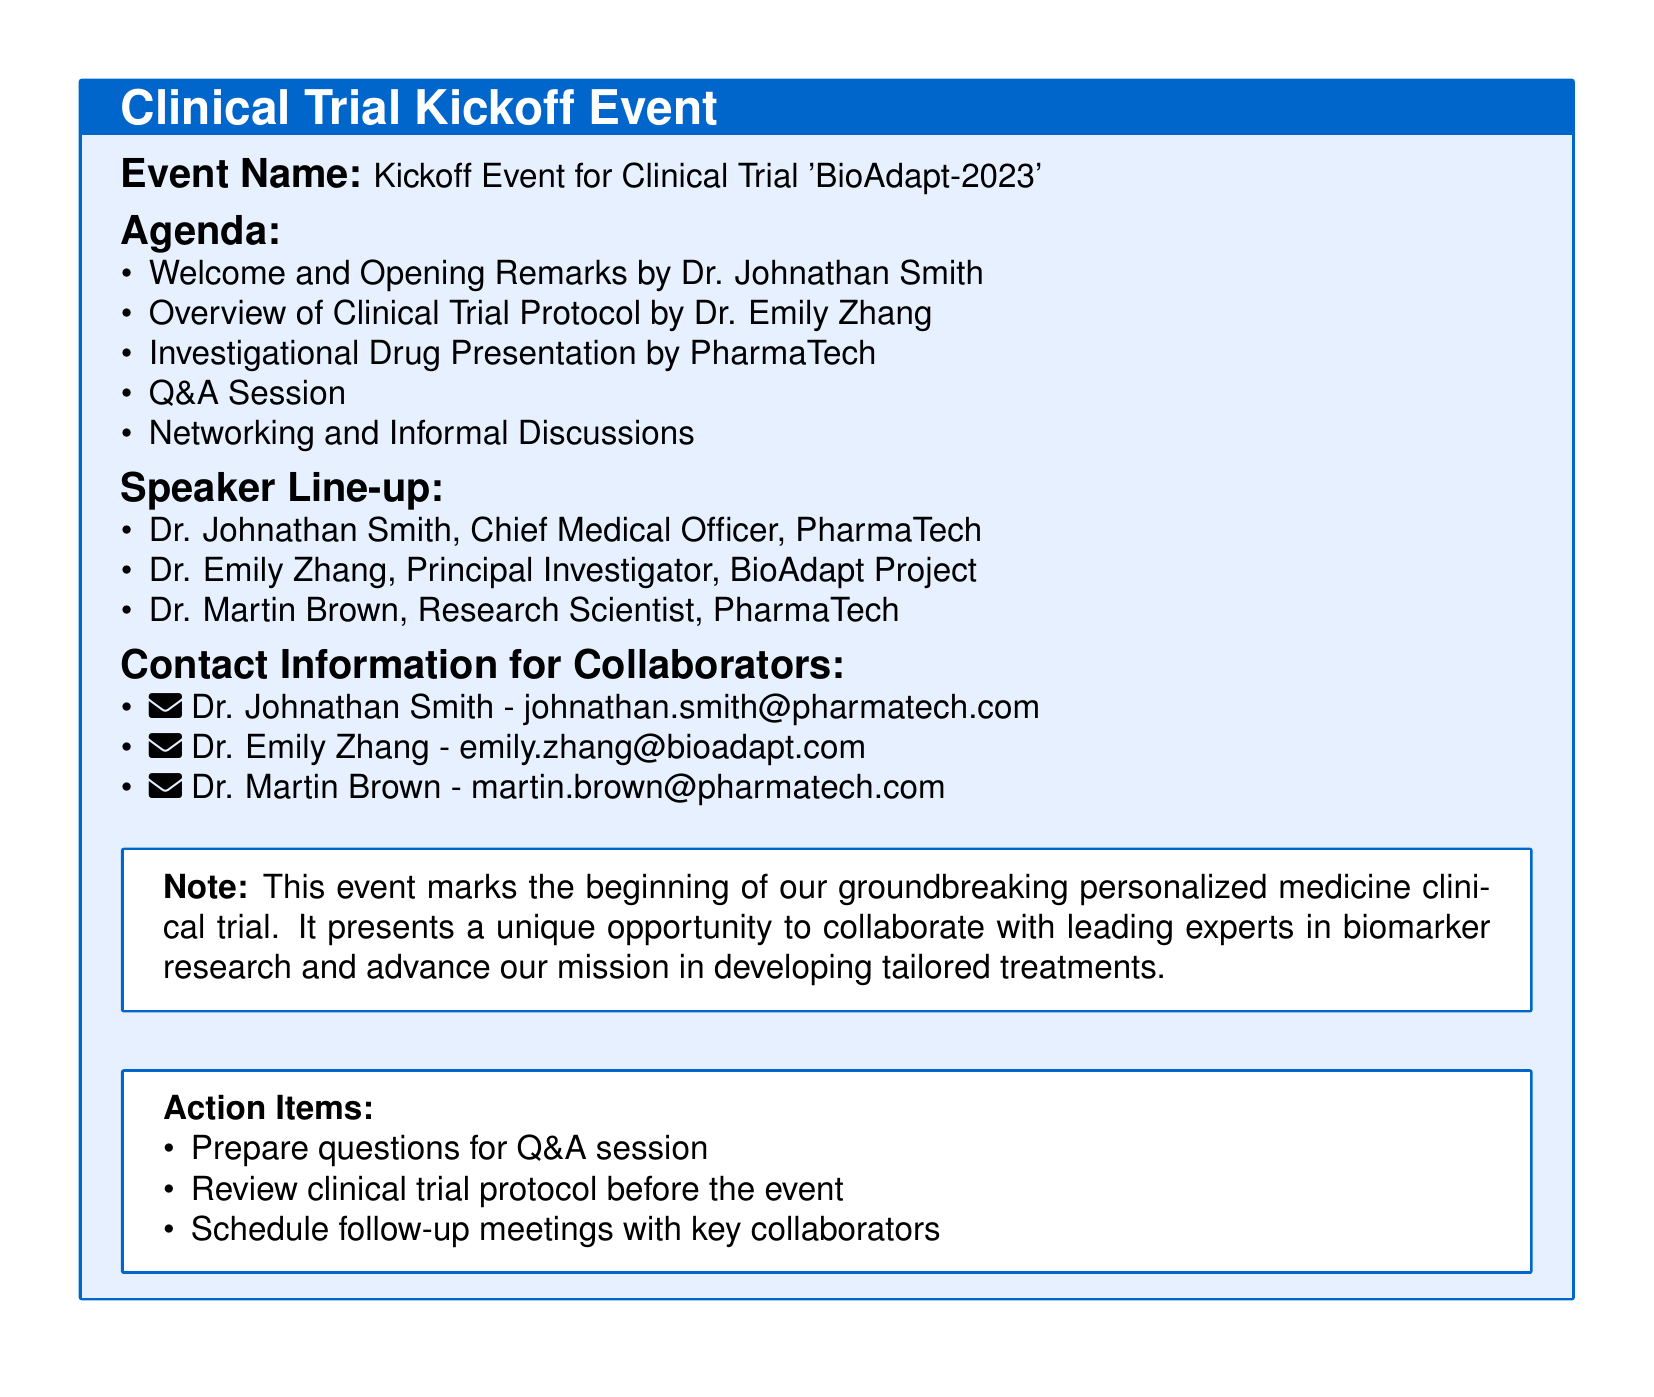What is the event name? The event name is provided under the title section in the document.
Answer: Kickoff Event for Clinical Trial 'BioAdapt-2023' Who is giving the opening remarks? The person responsible for opening remarks is listed in the agenda section.
Answer: Dr. Johnathan Smith How many speakers are listed for the event? The number of speakers is determined by counting the entries in the speaker line-up.
Answer: Three What is one action item mentioned in the document? Action items are listed in a specific section of the document.
Answer: Prepare questions for Q&A session What is the email address of Dr. Emily Zhang? The email addresses are provided in the contact information section.
Answer: emily.zhang@bioadapt.com What is the purpose of the event? The purpose of the event is summarized in the note section at the end of the document.
Answer: Groundbreaking personalized medicine clinical trial Who is the principal investigator mentioned? The principal investigator is specifically named in the speaker line-up.
Answer: Dr. Emily Zhang What should participants do before the event? The agenda and action items suggest what needs to be done prior to the event.
Answer: Review clinical trial protocol before the event Which company is involved in the investigational drug presentation? The company responsible for the presentation is identified in the agenda.
Answer: PharmaTech 